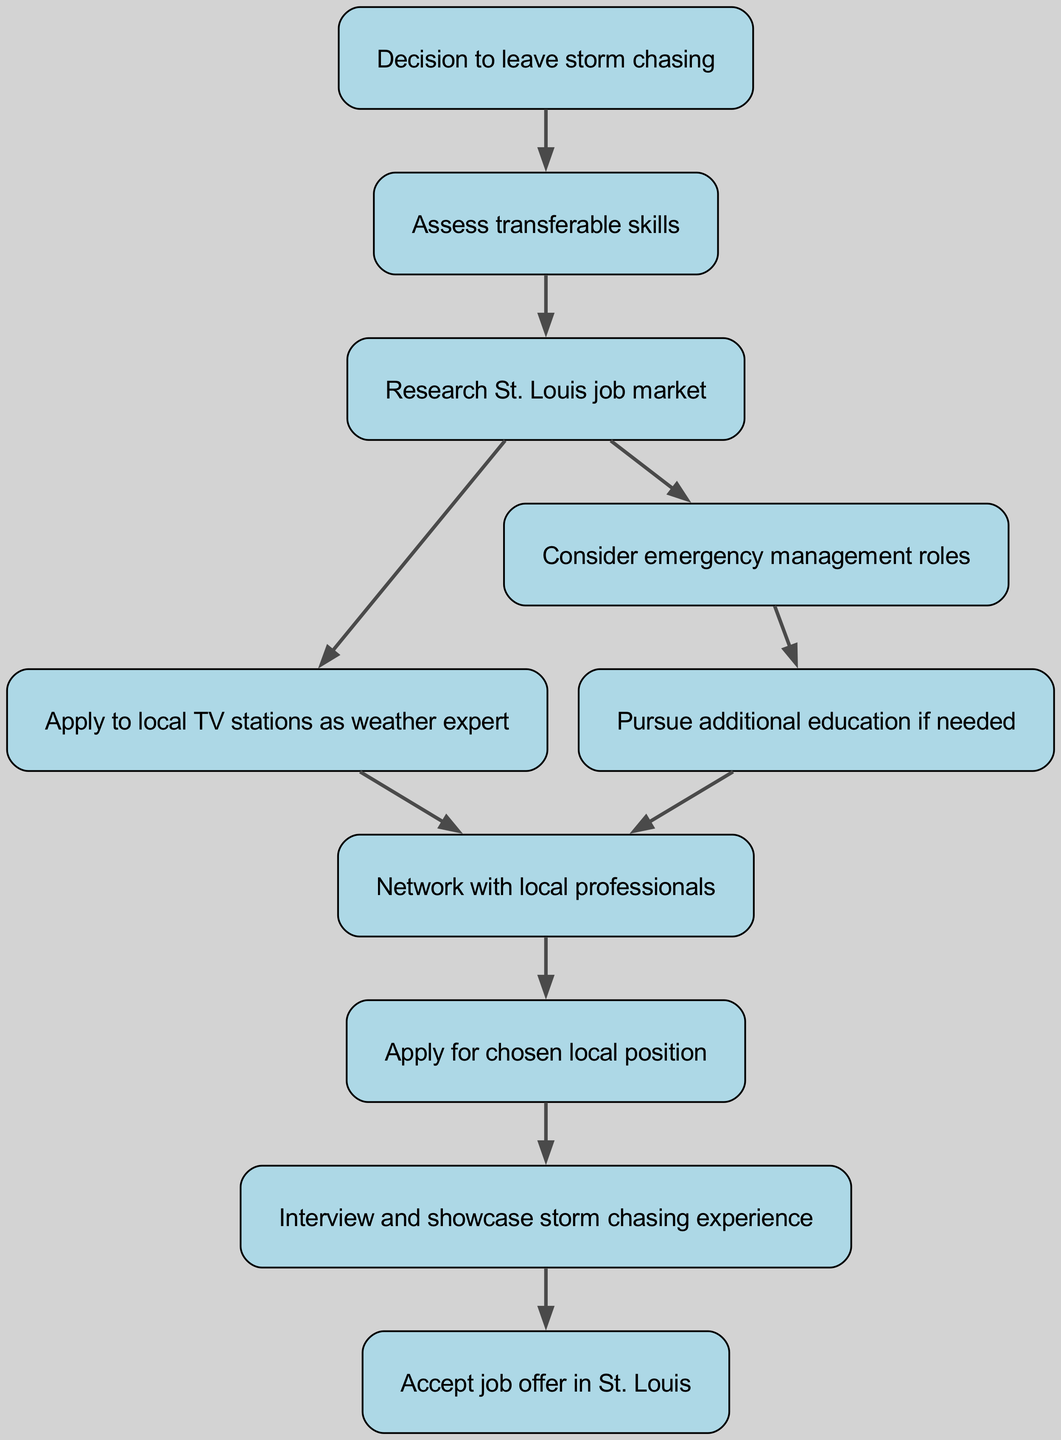What is the first step in the flow chart? The first step in the flow chart is identified as "Decision to leave storm chasing," which is labeled as the starting point. This node directs the flow to the next step, assessing transferable skills.
Answer: Decision to leave storm chasing How many nodes are present in the diagram? The diagram contains 10 nodes in total, each representing a key step in the career transition process. Counting from the starting point to the final job acceptance gives us a total of 10 distinct points.
Answer: 10 What is the node following "Assess transferable skills"? The node directly following "Assess transferable skills" is "Research St. Louis job market." This indicates the next logical step after evaluating the skills acquired from storm chasing.
Answer: Research St. Louis job market Which two nodes can be reached after "Research St. Louis job market"? The two nodes that can be reached after "Research St. Louis job market" are "Apply to local TV stations as weather expert" and "Consider emergency management roles." This shows that there are two potential paths to take after researching the job market.
Answer: Apply to local TV stations as weather expert and Consider emergency management roles What is the final step in this flow chart? The final step in the flow chart is "Accept job offer in St. Louis." This node represents the ultimate goal of the entire process, where the individual accepts a position in their new career.
Answer: Accept job offer in St. Louis What actions are suggested after considering emergency management roles? After considering emergency management roles, the flow suggests pursuing additional education if needed. This indicates a potential need for further qualifications before moving forward in that career path.
Answer: Pursue additional education if needed How do you move from "Network with local professionals" to the next step? To move from "Network with local professionals," you would apply for the chosen local position. Networking is a crucial step that facilitates the application process by forming connections with others in the field.
Answer: Apply for chosen local position What is the significance of the node "Interview and showcase storm chasing experience"? The node "Interview and showcase storm chasing experience" signifies an important stage in the process where the individual presents their unique background and skills to potential employers, leveraging their previous storm chasing experience in the job application process.
Answer: Interview and showcase storm chasing experience 